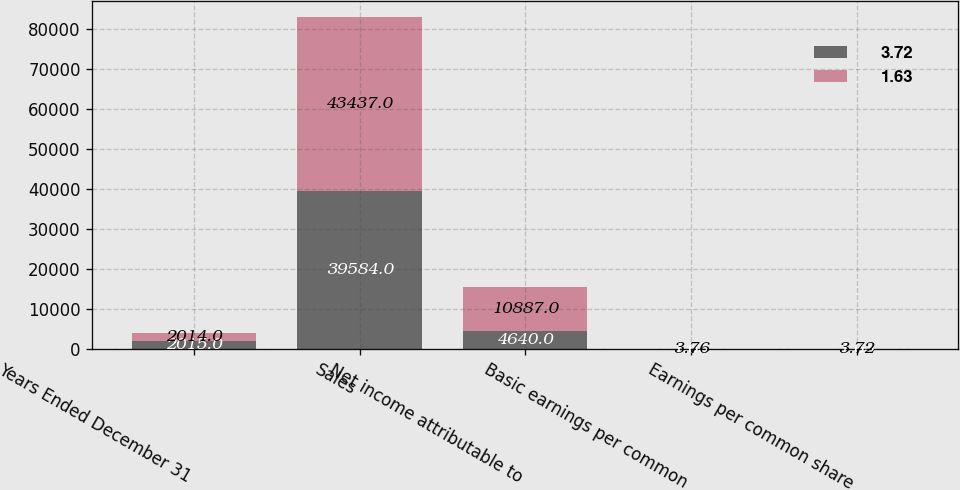<chart> <loc_0><loc_0><loc_500><loc_500><stacked_bar_chart><ecel><fcel>Years Ended December 31<fcel>Sales<fcel>Net income attributable to<fcel>Basic earnings per common<fcel>Earnings per common share<nl><fcel>3.72<fcel>2015<fcel>39584<fcel>4640<fcel>1.65<fcel>1.63<nl><fcel>1.63<fcel>2014<fcel>43437<fcel>10887<fcel>3.76<fcel>3.72<nl></chart> 